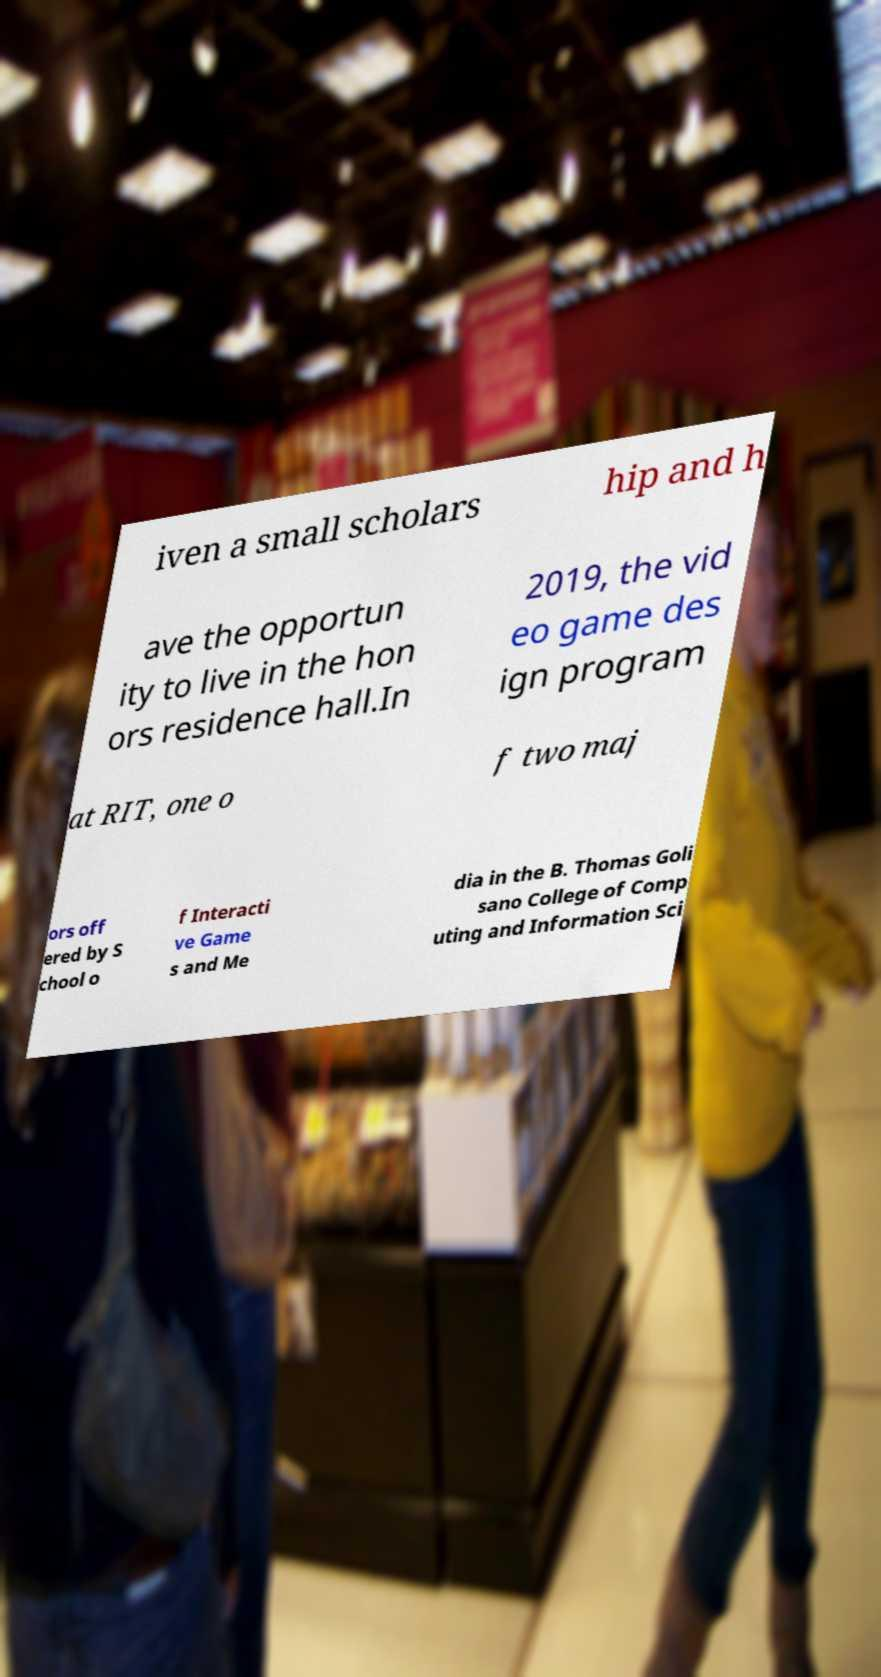Could you assist in decoding the text presented in this image and type it out clearly? iven a small scholars hip and h ave the opportun ity to live in the hon ors residence hall.In 2019, the vid eo game des ign program at RIT, one o f two maj ors off ered by S chool o f Interacti ve Game s and Me dia in the B. Thomas Goli sano College of Comp uting and Information Sci 